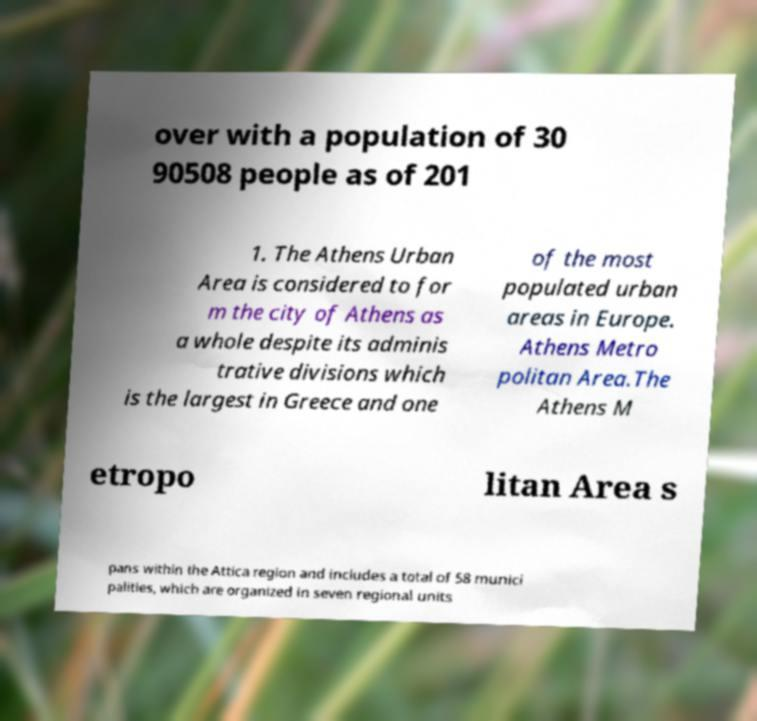There's text embedded in this image that I need extracted. Can you transcribe it verbatim? over with a population of 30 90508 people as of 201 1. The Athens Urban Area is considered to for m the city of Athens as a whole despite its adminis trative divisions which is the largest in Greece and one of the most populated urban areas in Europe. Athens Metro politan Area.The Athens M etropo litan Area s pans within the Attica region and includes a total of 58 munici palities, which are organized in seven regional units 